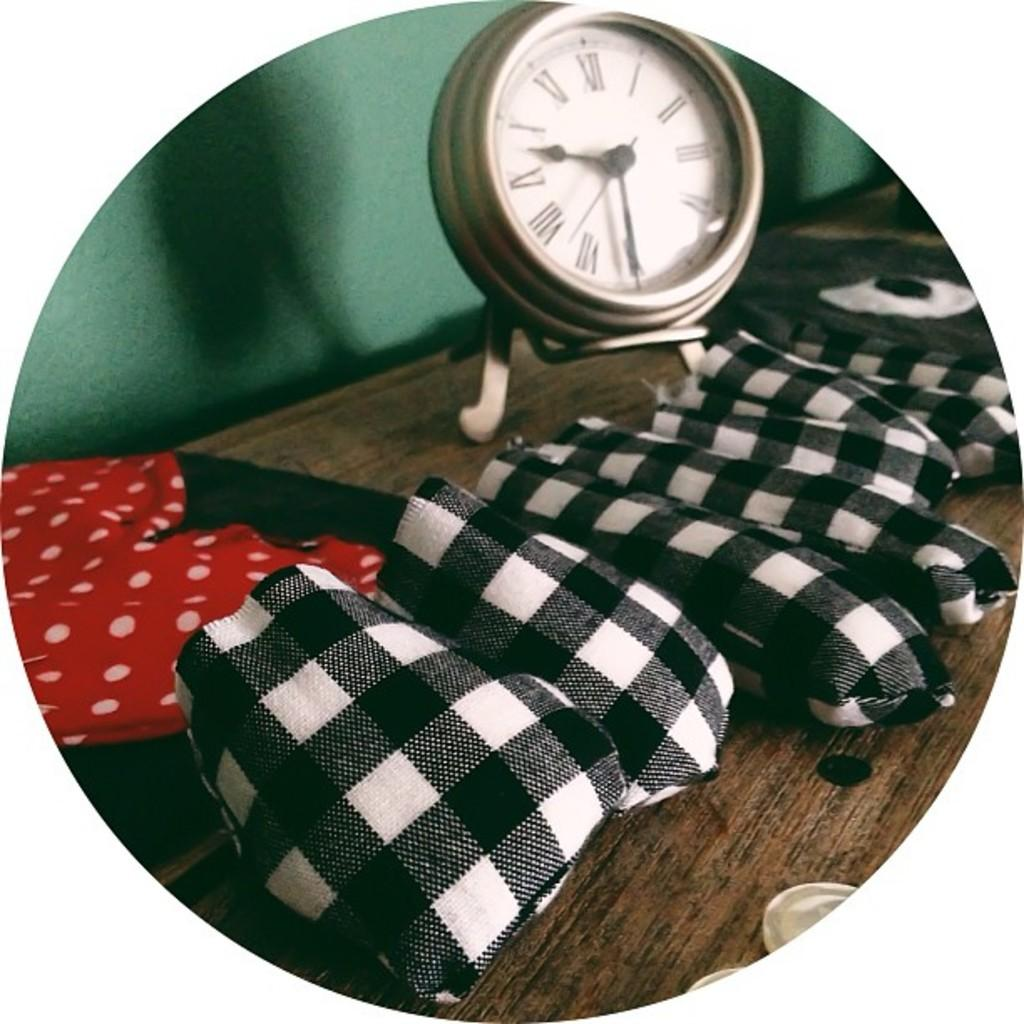<image>
Relay a brief, clear account of the picture shown. A round brushed-nickel clock portrays the time as 9:30. 